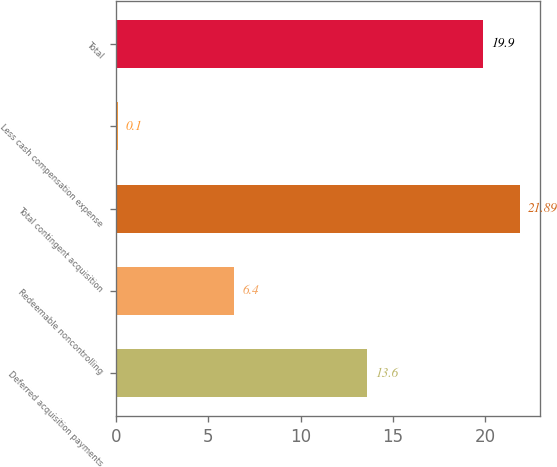Convert chart to OTSL. <chart><loc_0><loc_0><loc_500><loc_500><bar_chart><fcel>Deferred acquisition payments<fcel>Redeemable noncontrolling<fcel>Total contingent acquisition<fcel>Less cash compensation expense<fcel>Total<nl><fcel>13.6<fcel>6.4<fcel>21.89<fcel>0.1<fcel>19.9<nl></chart> 